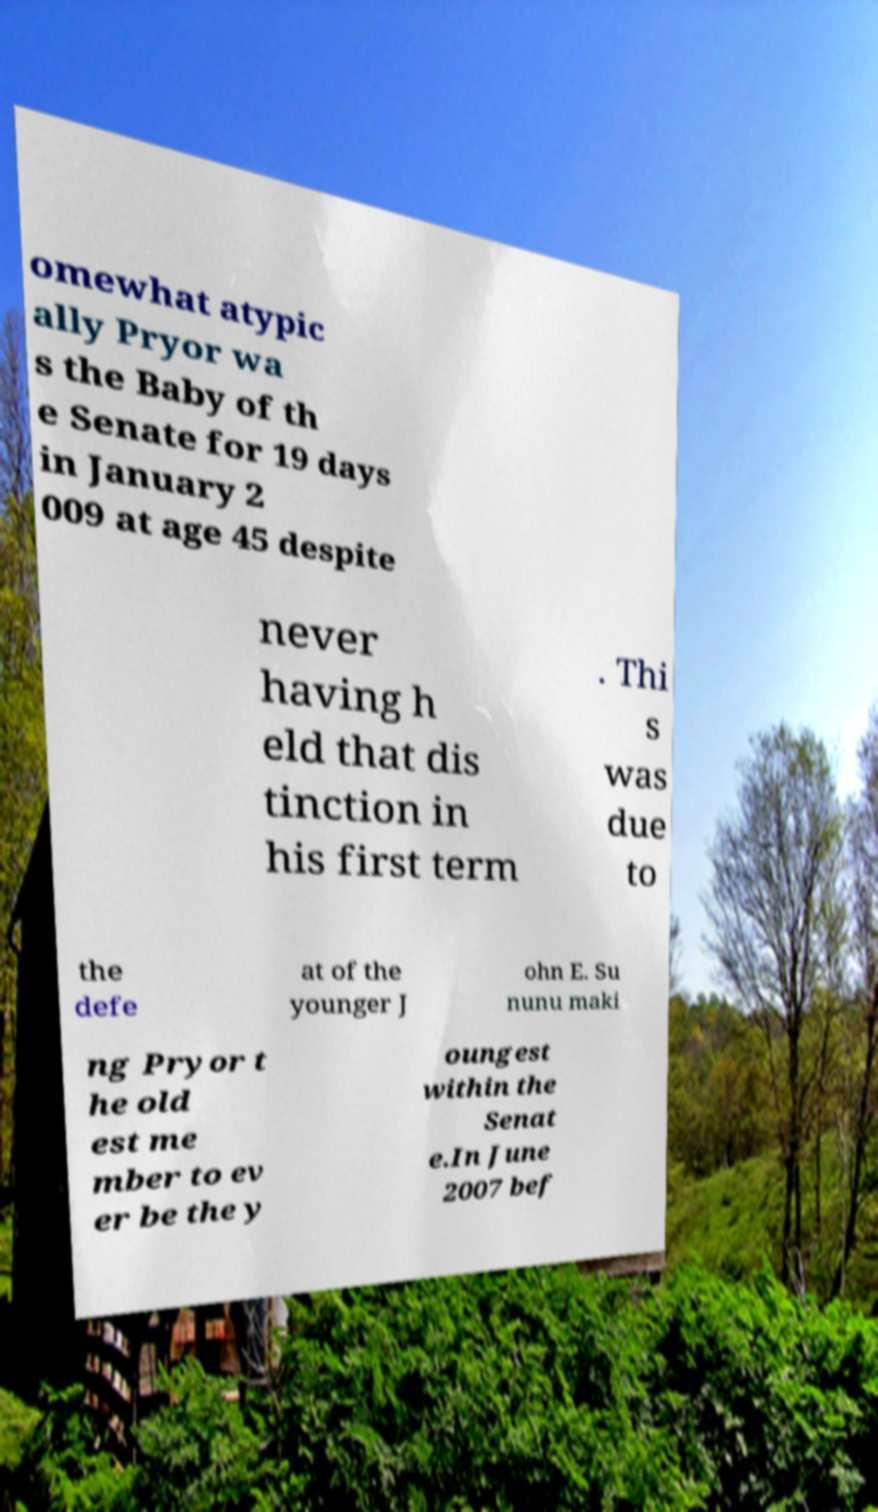Could you assist in decoding the text presented in this image and type it out clearly? omewhat atypic ally Pryor wa s the Baby of th e Senate for 19 days in January 2 009 at age 45 despite never having h eld that dis tinction in his first term . Thi s was due to the defe at of the younger J ohn E. Su nunu maki ng Pryor t he old est me mber to ev er be the y oungest within the Senat e.In June 2007 bef 